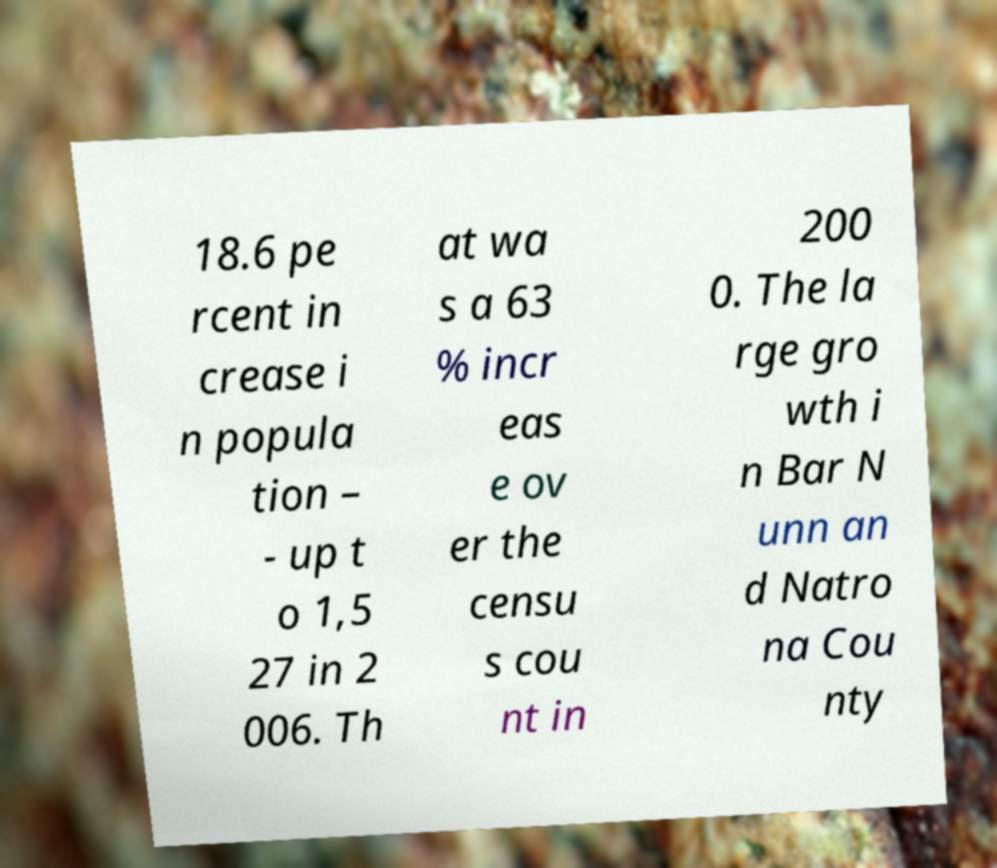For documentation purposes, I need the text within this image transcribed. Could you provide that? 18.6 pe rcent in crease i n popula tion – - up t o 1,5 27 in 2 006. Th at wa s a 63 % incr eas e ov er the censu s cou nt in 200 0. The la rge gro wth i n Bar N unn an d Natro na Cou nty 